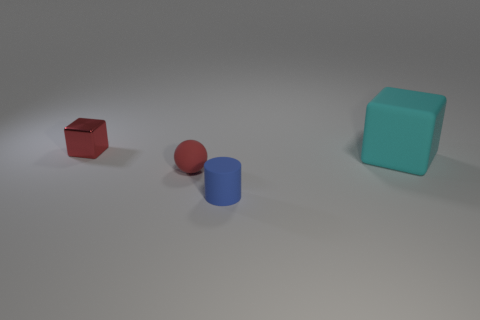What number of small things are both in front of the shiny block and on the left side of the tiny matte cylinder?
Make the answer very short. 1. What number of things are tiny red cubes or tiny objects that are in front of the big cyan rubber cube?
Make the answer very short. 3. Is the number of small metallic cubes greater than the number of yellow cubes?
Give a very brief answer. Yes. There is a red object to the right of the tiny metallic block; what is its shape?
Give a very brief answer. Sphere. What number of other red shiny objects are the same shape as the red metallic object?
Make the answer very short. 0. How big is the block left of the block in front of the metal block?
Your answer should be compact. Small. How many blue things are either large metal things or cylinders?
Offer a very short reply. 1. Is the number of tiny shiny cubes that are on the right side of the large rubber object less than the number of big cyan matte cubes to the left of the blue thing?
Your answer should be very brief. No. There is a red matte object; is it the same size as the matte object that is in front of the small red rubber object?
Keep it short and to the point. Yes. How many blocks are the same size as the red matte ball?
Your response must be concise. 1. 